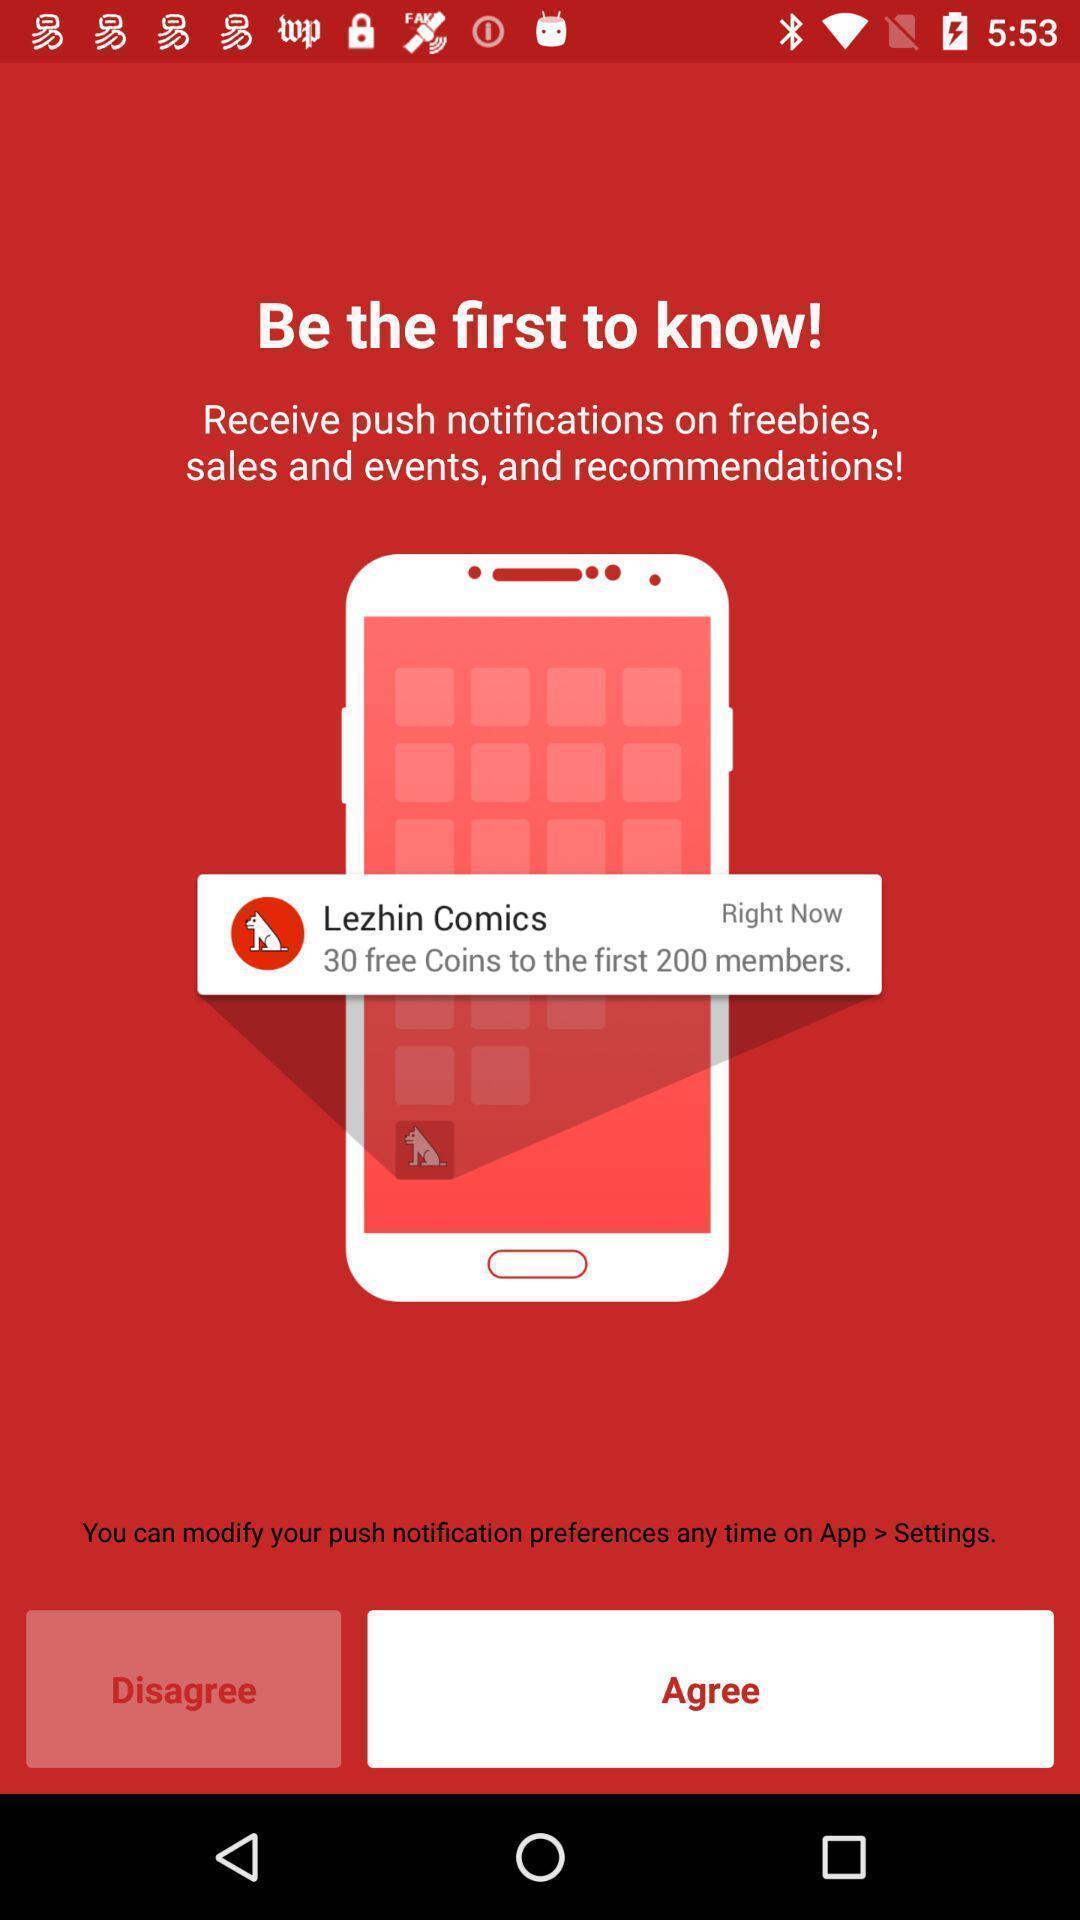What is the overall content of this screenshot? Page displays to agree notifications in app. 